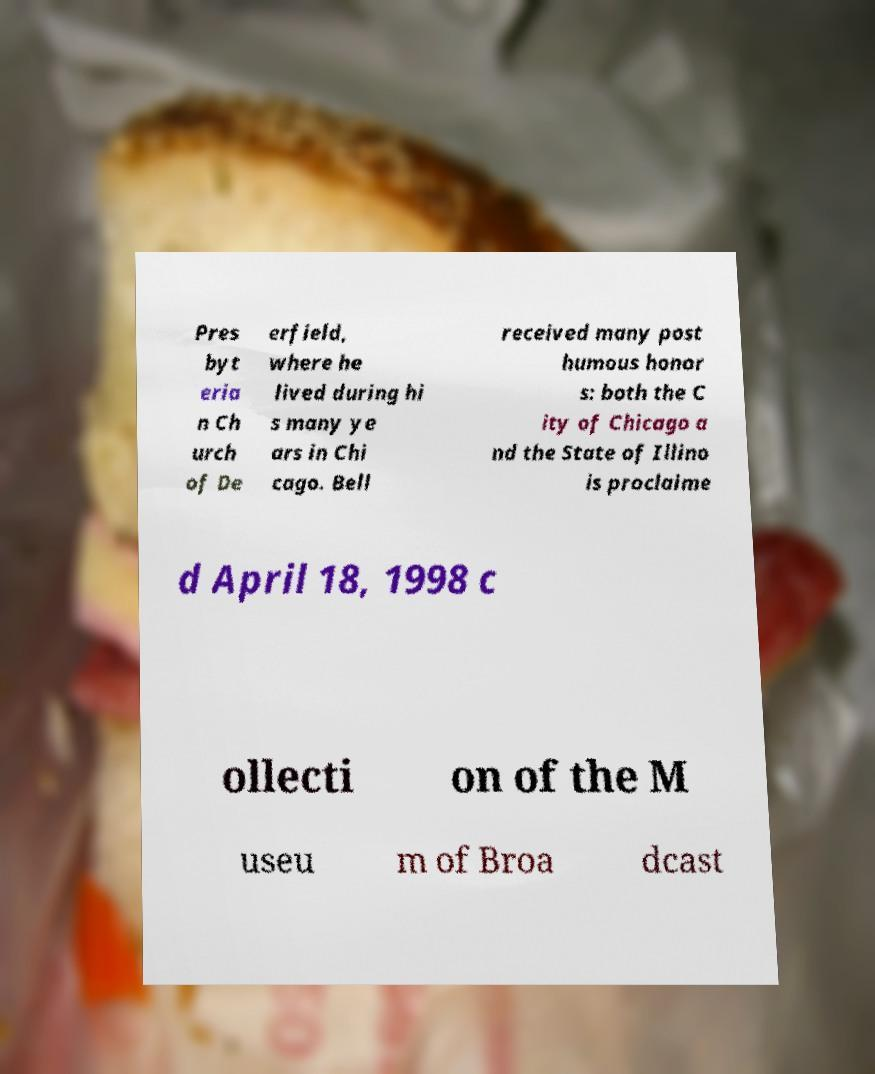I need the written content from this picture converted into text. Can you do that? Pres byt eria n Ch urch of De erfield, where he lived during hi s many ye ars in Chi cago. Bell received many post humous honor s: both the C ity of Chicago a nd the State of Illino is proclaime d April 18, 1998 c ollecti on of the M useu m of Broa dcast 